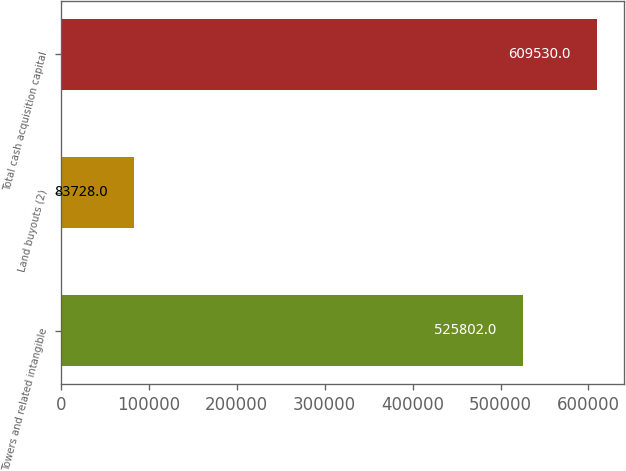Convert chart. <chart><loc_0><loc_0><loc_500><loc_500><bar_chart><fcel>Towers and related intangible<fcel>Land buyouts (2)<fcel>Total cash acquisition capital<nl><fcel>525802<fcel>83728<fcel>609530<nl></chart> 